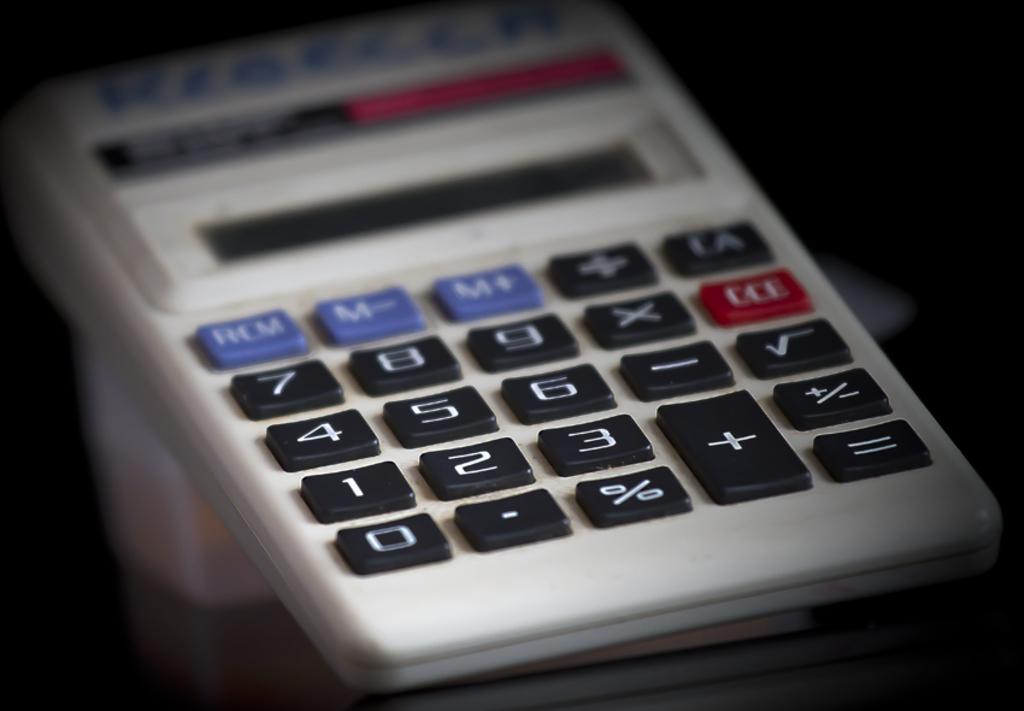<image>
Offer a succinct explanation of the picture presented. A small hand held calculater with Kiechler written in marker on the top. 